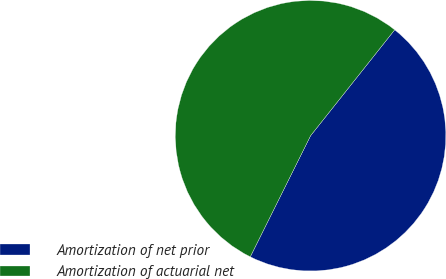Convert chart to OTSL. <chart><loc_0><loc_0><loc_500><loc_500><pie_chart><fcel>Amortization of net prior<fcel>Amortization of actuarial net<nl><fcel>46.67%<fcel>53.33%<nl></chart> 